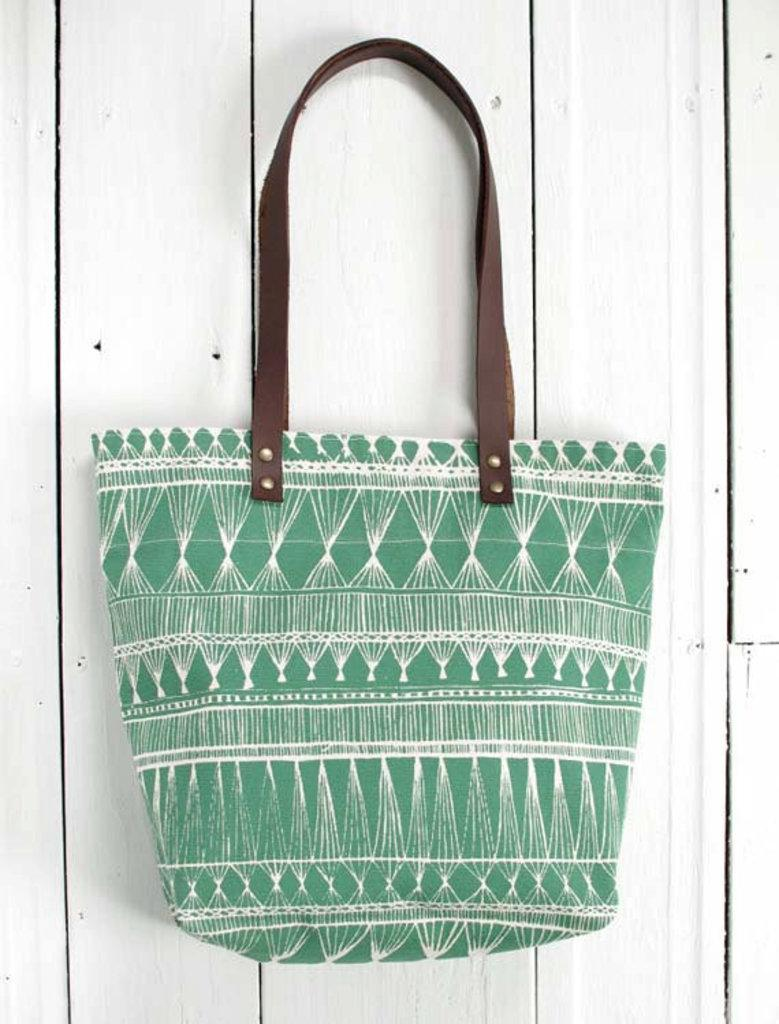What object is present in the image? There is a bag in the image. What color is the bag? The bag is green. Where is the bag located? The bag is placed on a table. What is the color of the bag's handle? The bag has a brown color handle. How many sheets are visible in the image? There are no sheets present in the image; it features a green bag with a brown handle placed on a table. 